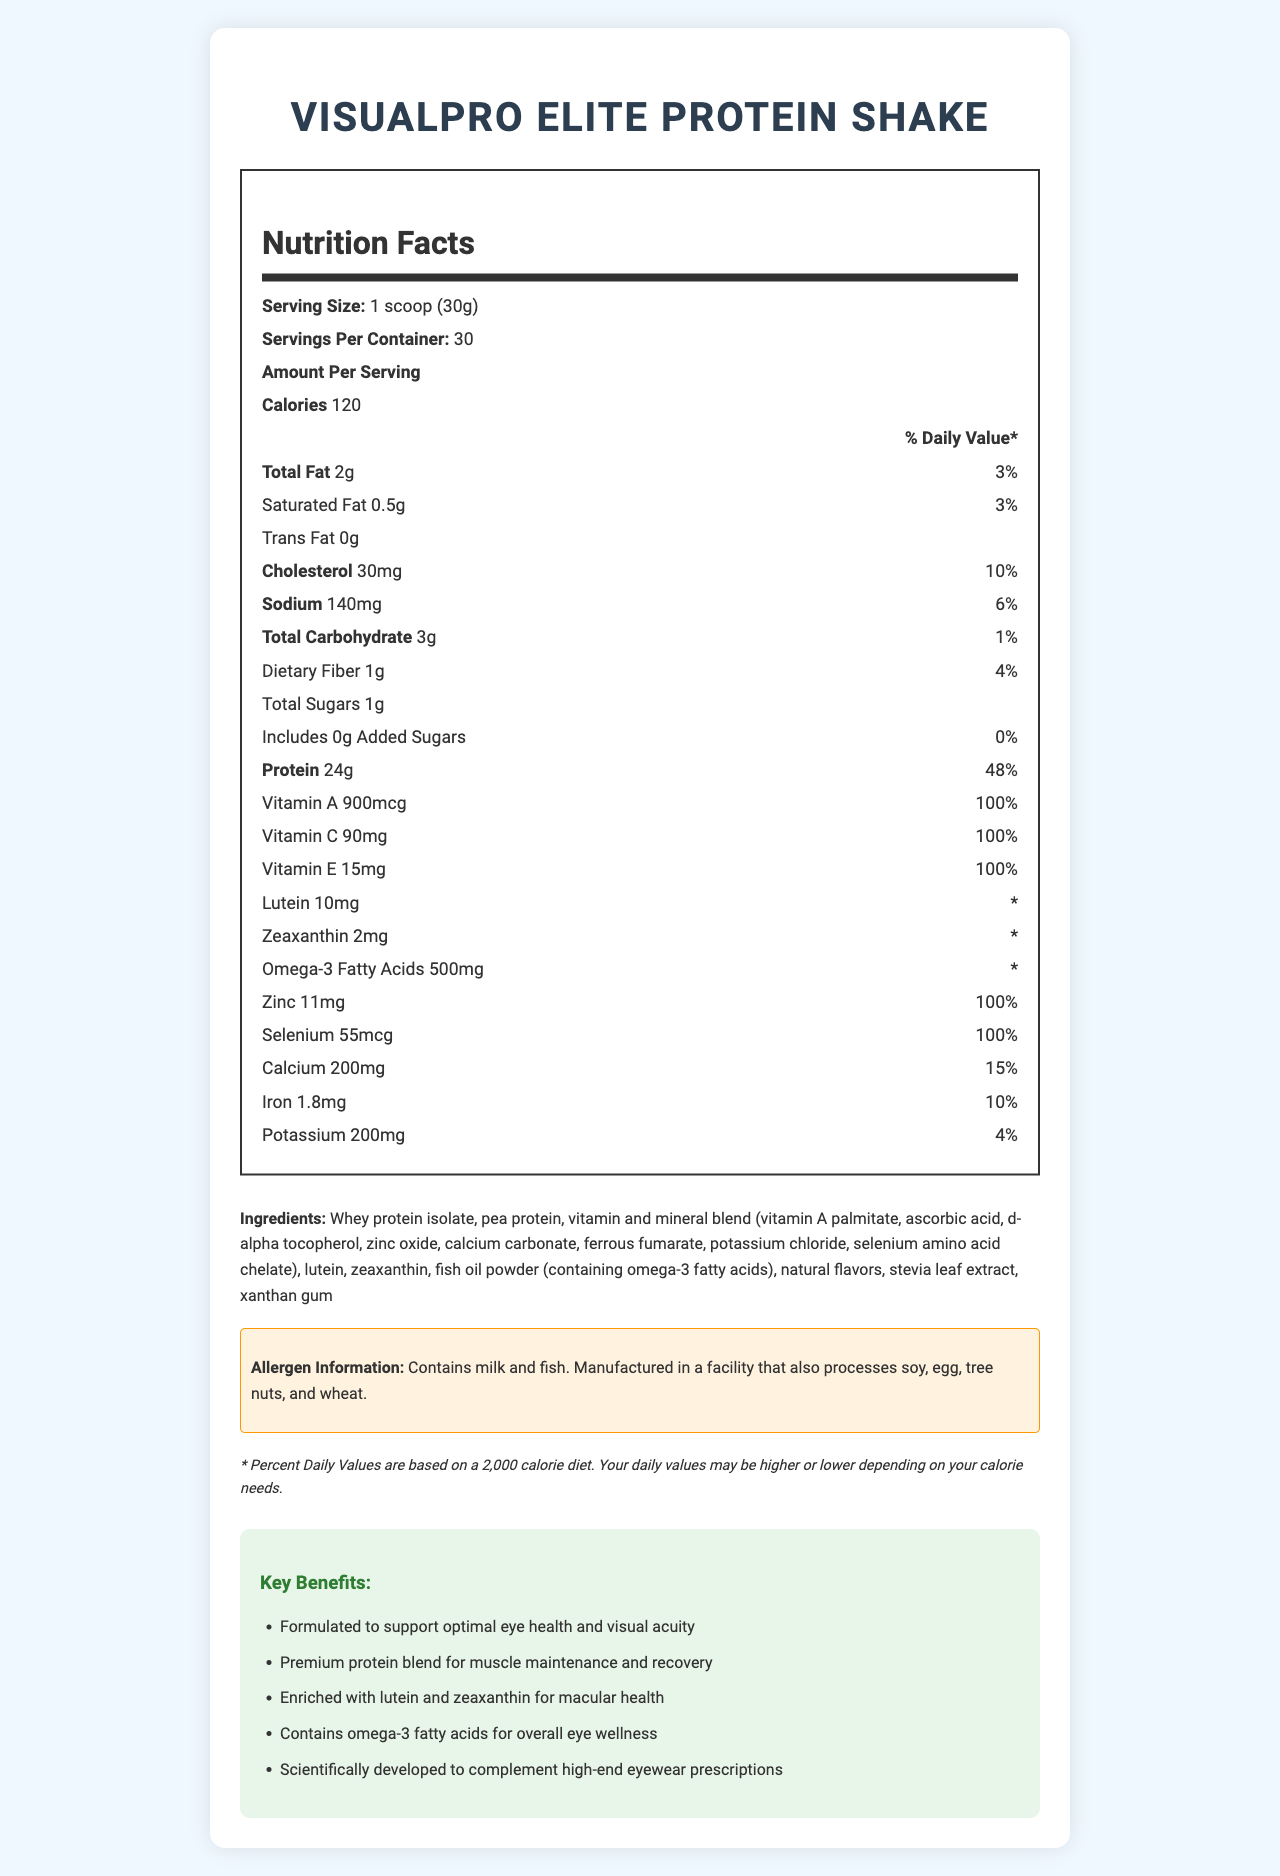how many calories are in each serving of VisualPro Elite Protein Shake? The label under 'Amount Per Serving' lists the calorie count as 120.
Answer: 120 what is the serving size for VisualPro Elite Protein Shake? The label specifies the serving size as '1 scoop (30g)'.
Answer: 1 scoop (30g) how much protein is in each serving? The label under 'Amount Per Serving' lists the protein content as 24g (48% Daily Value).
Answer: 24g does the VisualPro Elite Protein Shake contain any dietary fiber? The label lists dietary fiber content as 1g (4% Daily Value).
Answer: Yes what allergen information is provided for VisualPro Elite Protein Shake? The allergen information is found in a highlighted section stating "Contains milk and fish. Manufactured in a facility that also processes soy, egg, tree nuts, and wheat."
Answer: Contains milk and fish. Manufactured in a facility that also processes soy, egg, tree nuts, and wheat. what vitamins and minerals are included in the VisualPro Elite Protein Shake? The label lists these vitamins and minerals: Vitamin A, Vitamin C, Vitamin E, Zinc, Selenium, Calcium, Iron, and Potassium.
Answer: Vitamin A, Vitamin C, Vitamin E, Zinc, Selenium, Calcium, Iron, Potassium how much calcium is in each serving? The label lists the calcium content as 200mg, which is 15% of the daily value.
Answer: 200mg (15% DV) The protein content in each serving of VisualPro Elite Protein Shake is:  
I. 12g  
II. 18g  
III. 24g  
IV. 30g The label lists the protein content as 24g per serving.
Answer: III. 24g which nutrient has the highest daily value percentage in one serving?  
1. Vitamin C  
2. Total Fat  
3. Sodium  
4. Iron The label indicates that Vitamin C has a daily value percentage of 100%, which is higher than the other options listed.
Answer: 1. Vitamin C is there any trans fat in VisualPro Elite Protein Shake? The label lists trans fat content as 0g.
Answer: No summarize the main idea of the VisualPro Elite Protein Shake Nutrition Facts. The VisualPro Elite Protein Shake is marketed as a premium protein supplement that enhances visual health. It includes a blend of high-protein content and essential nutrients, with specific ingredients promoting eye wellness. It targets customers seeking to support both their physical and eye health.
Answer: The VisualPro Elite Protein Shake is a high-quality protein supplement formulated to support eye health and visual acuity. It provides 24g of protein per serving, along with essential vitamins and minerals, including Vitamin A, C, E, and Zinc. It also contains beneficial ingredients like lutein, zeaxanthin, and omega-3 fatty acids, which are recognized for their roles in maintaining eye health. The shake has been specifically designed to complement high-end eyewear prescriptions. what are the marketing claims of the VisualPro Elite Protein Shake? The marketing claims listed in the document include these benefits related to eye health, protein support, and complementing eyewear.
Answer: Formulated to support optimal eye health and visual acuity, Premium protein blend for muscle maintenance and recovery, Enriched with lutein and zeaxanthin for macular health, Contains omega-3 fatty acids for overall eye wellness, Scientifically developed to complement high-end eyewear prescriptions how does VisualPro Elite Protein Shake support eye health? The nutrient list shows that it contains ingredients known for their positive impacts on eye health, as highlighted in the marketing claims.
Answer: It is enriched with lutein, zeaxanthin, omega-3 fatty acids, Vitamin A, C, and E, all of which are known to support eye health and visual acuity. what is the source of omega-3 fatty acids in VisualPro Elite Protein Shake? The ingredients list specifies fish oil powder as the source of omega-3 fatty acids.
Answer: Fish oil powder how many servings are contained in one container of VisualPro Elite Protein Shake? The label lists 'Servings Per Container' as 30.
Answer: 30 how many grams of total sugars are in each serving? The label under 'Amount Per Serving' lists the total sugars content as 1g.
Answer: 1g does the VisualPro Elite Protein Shake contain any added sugars? The label lists added sugars content as 0g (0% Daily Value).
Answer: No what is the function of xanthan gum in the ingredients list? The document does not provide information about the function of individual ingredients like xanthan gum.
Answer: I don't know 